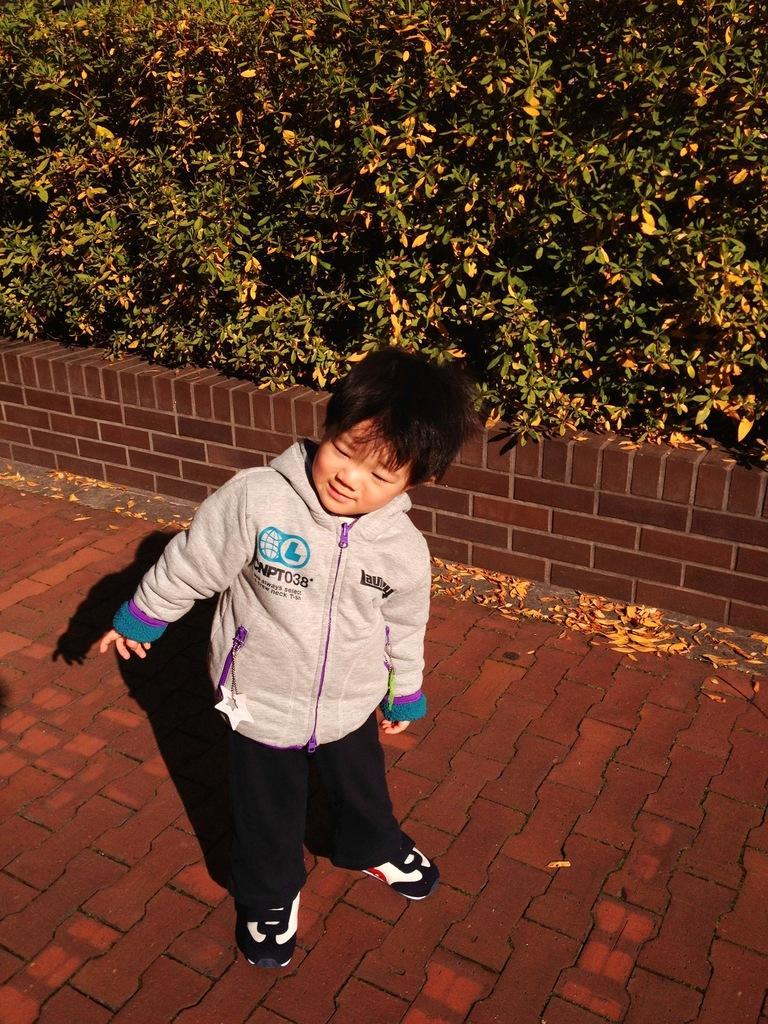What is the main subject of the image? There is a kid standing in the image. What type of flooring is visible at the bottom of the image? There are tiles at the bottom of the image. What type of vegetation is visible at the bottom of the image? There are leaves at the bottom of the image. What can be seen in the background of the image? There are trees in the background of the image. Is the kid sinking in quicksand in the image? No, there is no quicksand present in the image. How many boys are visible in the image? The image only features one kid, not multiple boys. 